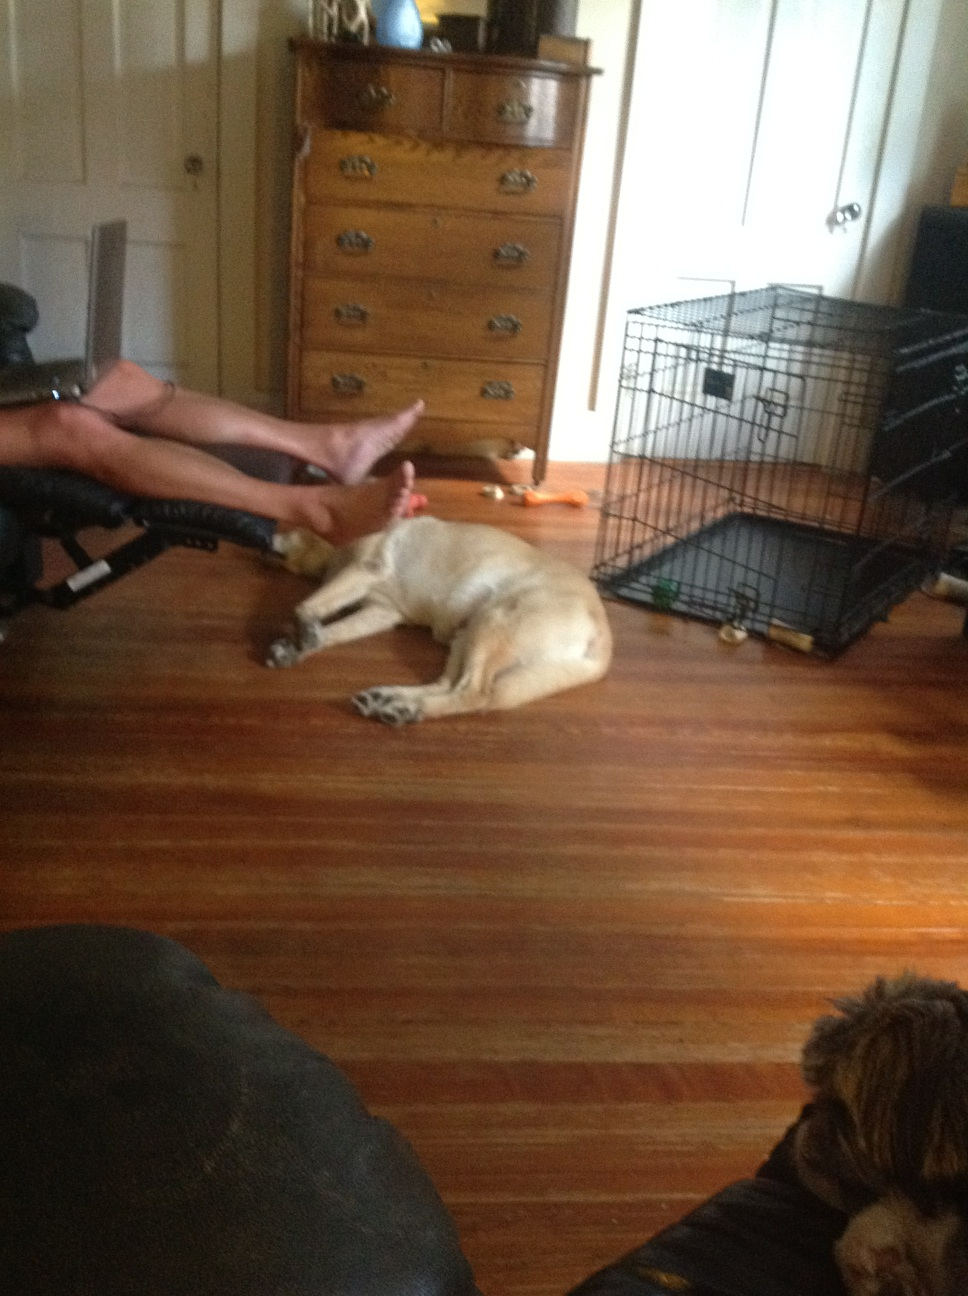Tell me more about the pets we can see. In this image, there are at least two dogs. The one lying down on the wooden floor has a light tan coat and seems to be taking a rest, stretching out with ease. The other dog appears to be smaller and has a darker coat, it's sitting near the chair, partially obscured from view. The presence of a metal pet crate suggests these pets are well-cared for and have their own space within the home. 